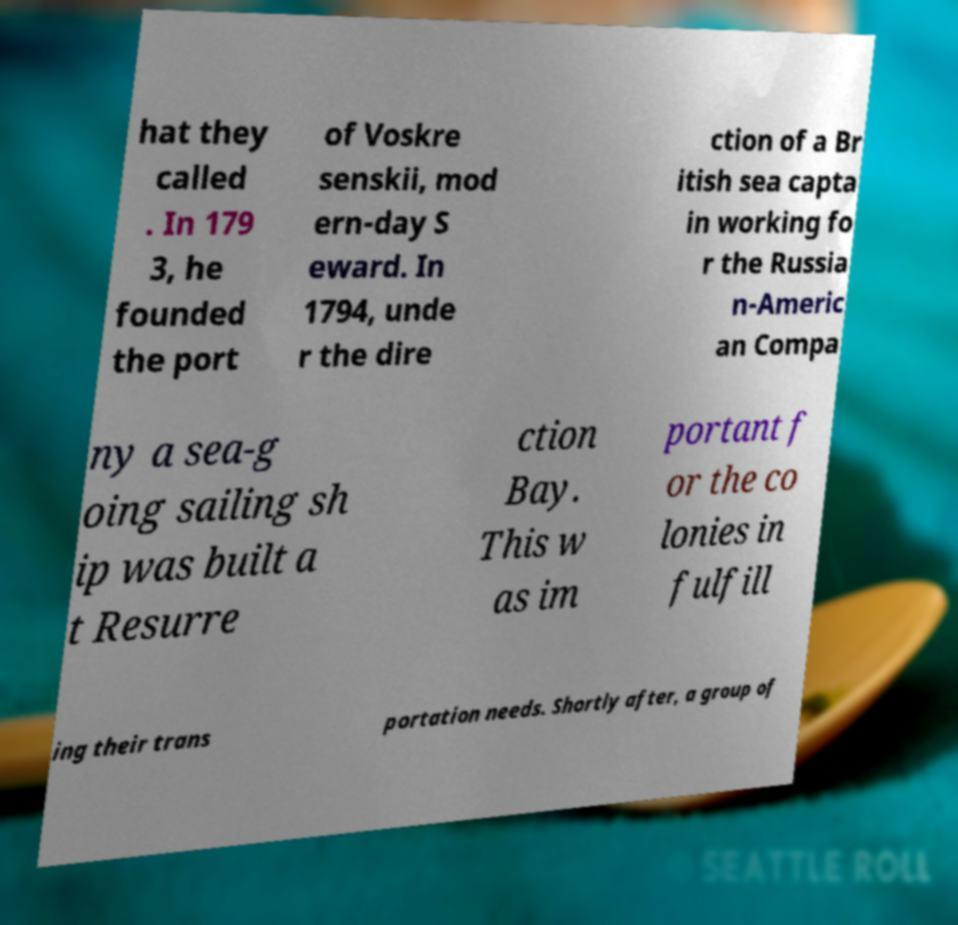Please identify and transcribe the text found in this image. hat they called . In 179 3, he founded the port of Voskre senskii, mod ern-day S eward. In 1794, unde r the dire ction of a Br itish sea capta in working fo r the Russia n-Americ an Compa ny a sea-g oing sailing sh ip was built a t Resurre ction Bay. This w as im portant f or the co lonies in fulfill ing their trans portation needs. Shortly after, a group of 